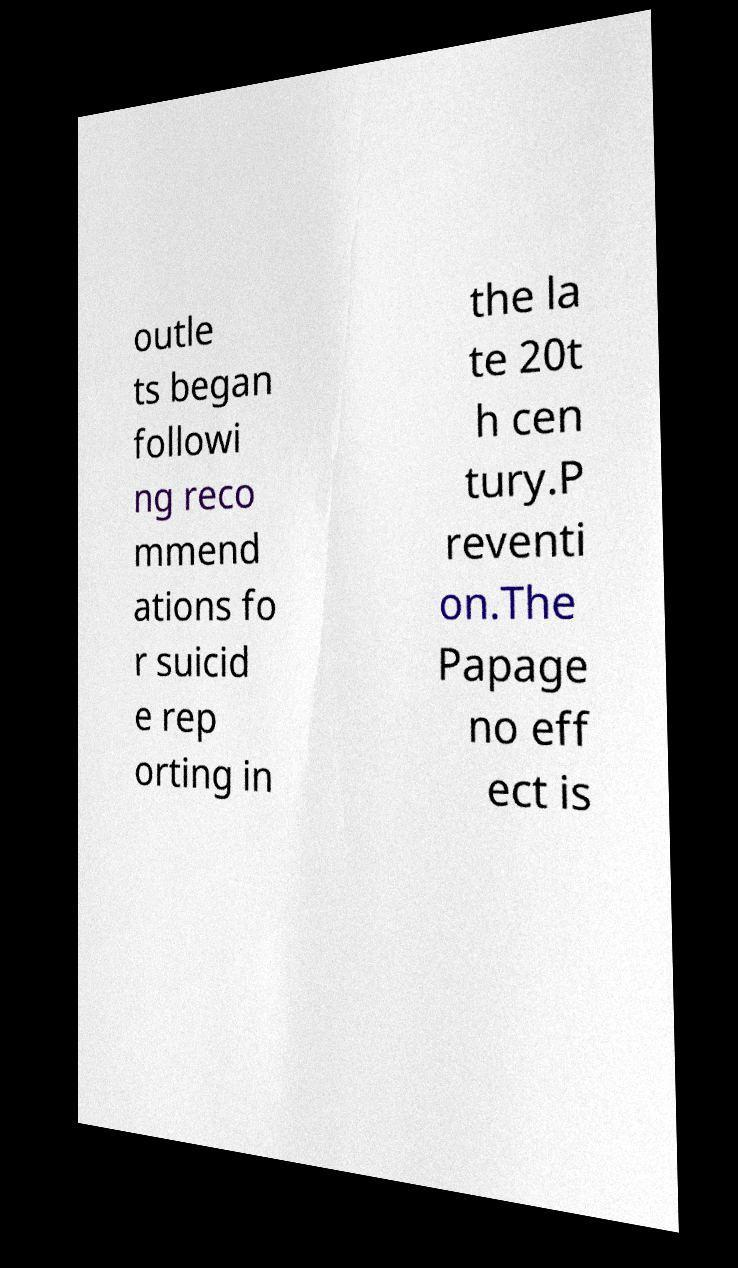Can you accurately transcribe the text from the provided image for me? outle ts began followi ng reco mmend ations fo r suicid e rep orting in the la te 20t h cen tury.P reventi on.The Papage no eff ect is 